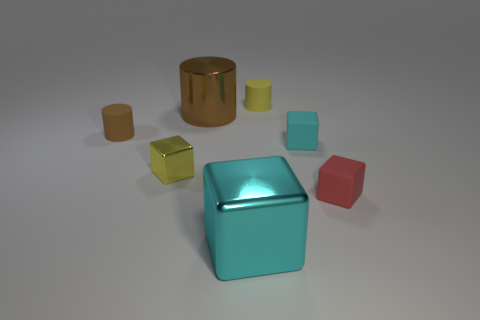Which object in the image appears to be the largest? The turquoise box-shaped object in the center appears to be the largest item in the image, based on its proportions relative to other items. 